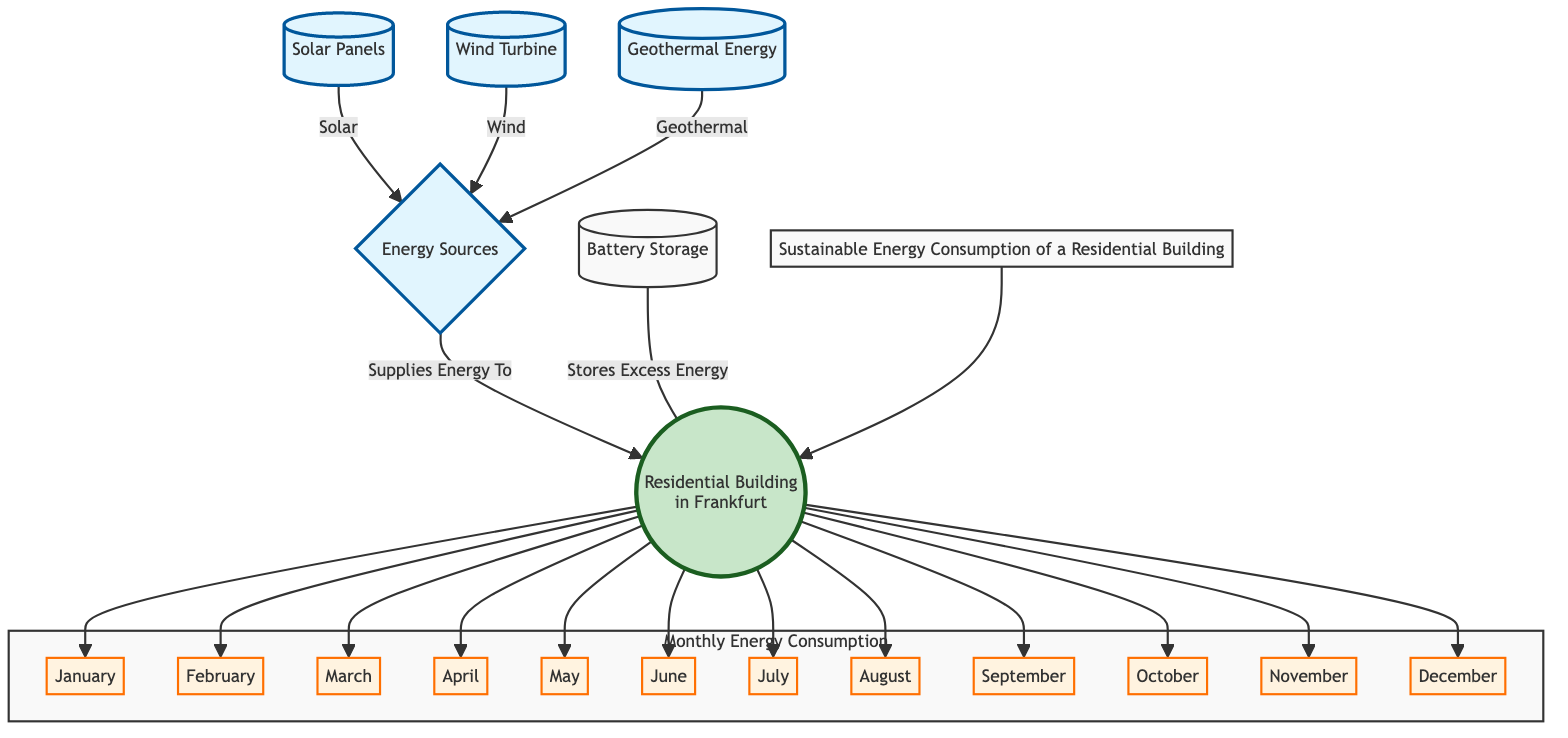What are the energy sources for the residential building? The diagram presents four energy sources: solar panels, wind turbine, geothermal energy, and battery storage. They all connect to the energy sources node, indicating they supply energy to the building.
Answer: Solar panels, wind turbine, geothermal energy, battery storage Which energy source is connected to the building directly? The building is connected to the energy sources node, which includes solar panels, wind turbine, and geothermal energy providing energy directly to the building. Battery storage is also mentioned but serves to store excess energy rather than directly supplying it.
Answer: Energy sources How many months are displayed in the diagram? The diagram illustrates twelve months, each represented as a separate node connected to the residential building. Counting these nodes reveals that there are indeed twelve months listed.
Answer: Twelve What is the relationship between battery storage and the residential building? Battery storage is connected to the building as a means to store excess energy produced by the energy sources, indicating that it plays a supportive role in energy management for the building.
Answer: Stores excess energy Which month is first in the monthly energy consumption breakdown? January is the first month displayed in a horizontal layout defining the monthly energy consumption breakdown.
Answer: January Which energy source is shown as providing solar energy? The solar panels are the energy source identified as providing solar energy to the energy sources node in the diagram.
Answer: Solar panels What is the main focus of the diagram? The primary focus of the diagram is on the sustainable energy consumption of a residential building, specifically how energy sources supply to it throughout the year.
Answer: Sustainable energy consumption How are the energy sources connected to the building? The energy sources are connected to the residential building with a labeled edge that signifies they supply energy to the building.
Answer: Supplies energy to 